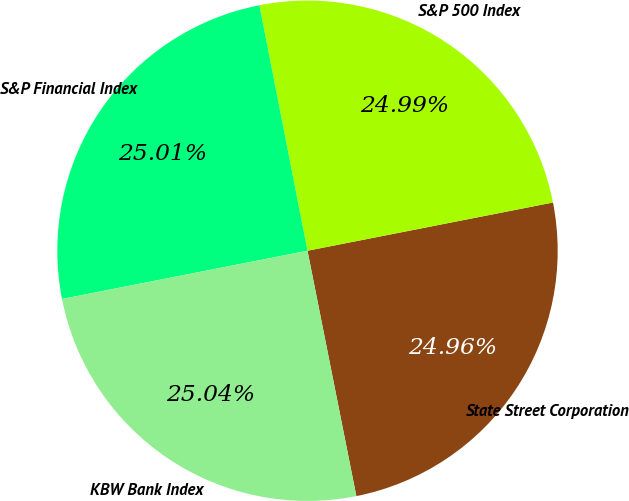Convert chart to OTSL. <chart><loc_0><loc_0><loc_500><loc_500><pie_chart><fcel>State Street Corporation<fcel>S&P 500 Index<fcel>S&P Financial Index<fcel>KBW Bank Index<nl><fcel>24.96%<fcel>24.99%<fcel>25.01%<fcel>25.04%<nl></chart> 